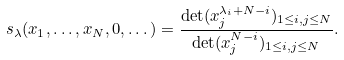Convert formula to latex. <formula><loc_0><loc_0><loc_500><loc_500>s _ { \lambda } ( x _ { 1 } , \dots , x _ { N } , 0 , \dots ) = \frac { \det ( x _ { j } ^ { \lambda _ { i } + N - i } ) _ { 1 \leq i , j \leq N } } { \det ( x _ { j } ^ { N - i } ) _ { 1 \leq i , j \leq N } } .</formula> 